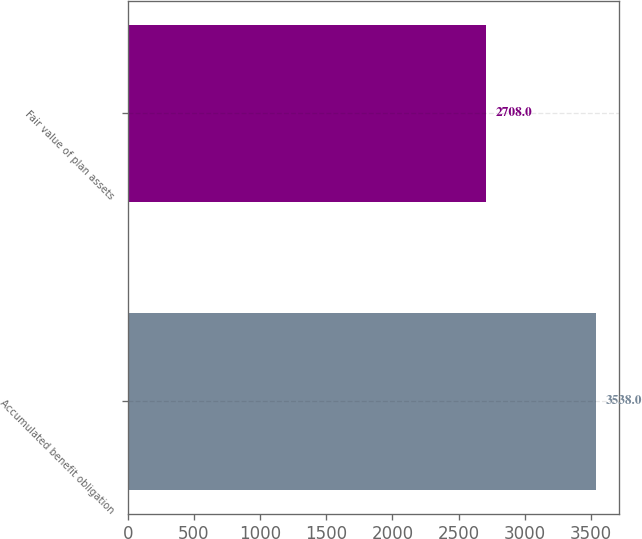Convert chart. <chart><loc_0><loc_0><loc_500><loc_500><bar_chart><fcel>Accumulated benefit obligation<fcel>Fair value of plan assets<nl><fcel>3538<fcel>2708<nl></chart> 